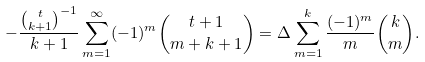<formula> <loc_0><loc_0><loc_500><loc_500>- \frac { \binom { t } { k + 1 } ^ { - 1 } } { k + 1 } \sum _ { m = 1 } ^ { \infty } ( - 1 ) ^ { m } \binom { t + 1 } { m + k + 1 } = \Delta \sum _ { m = 1 } ^ { k } \frac { ( - 1 ) ^ { m } } { m } \binom { k } { m } .</formula> 